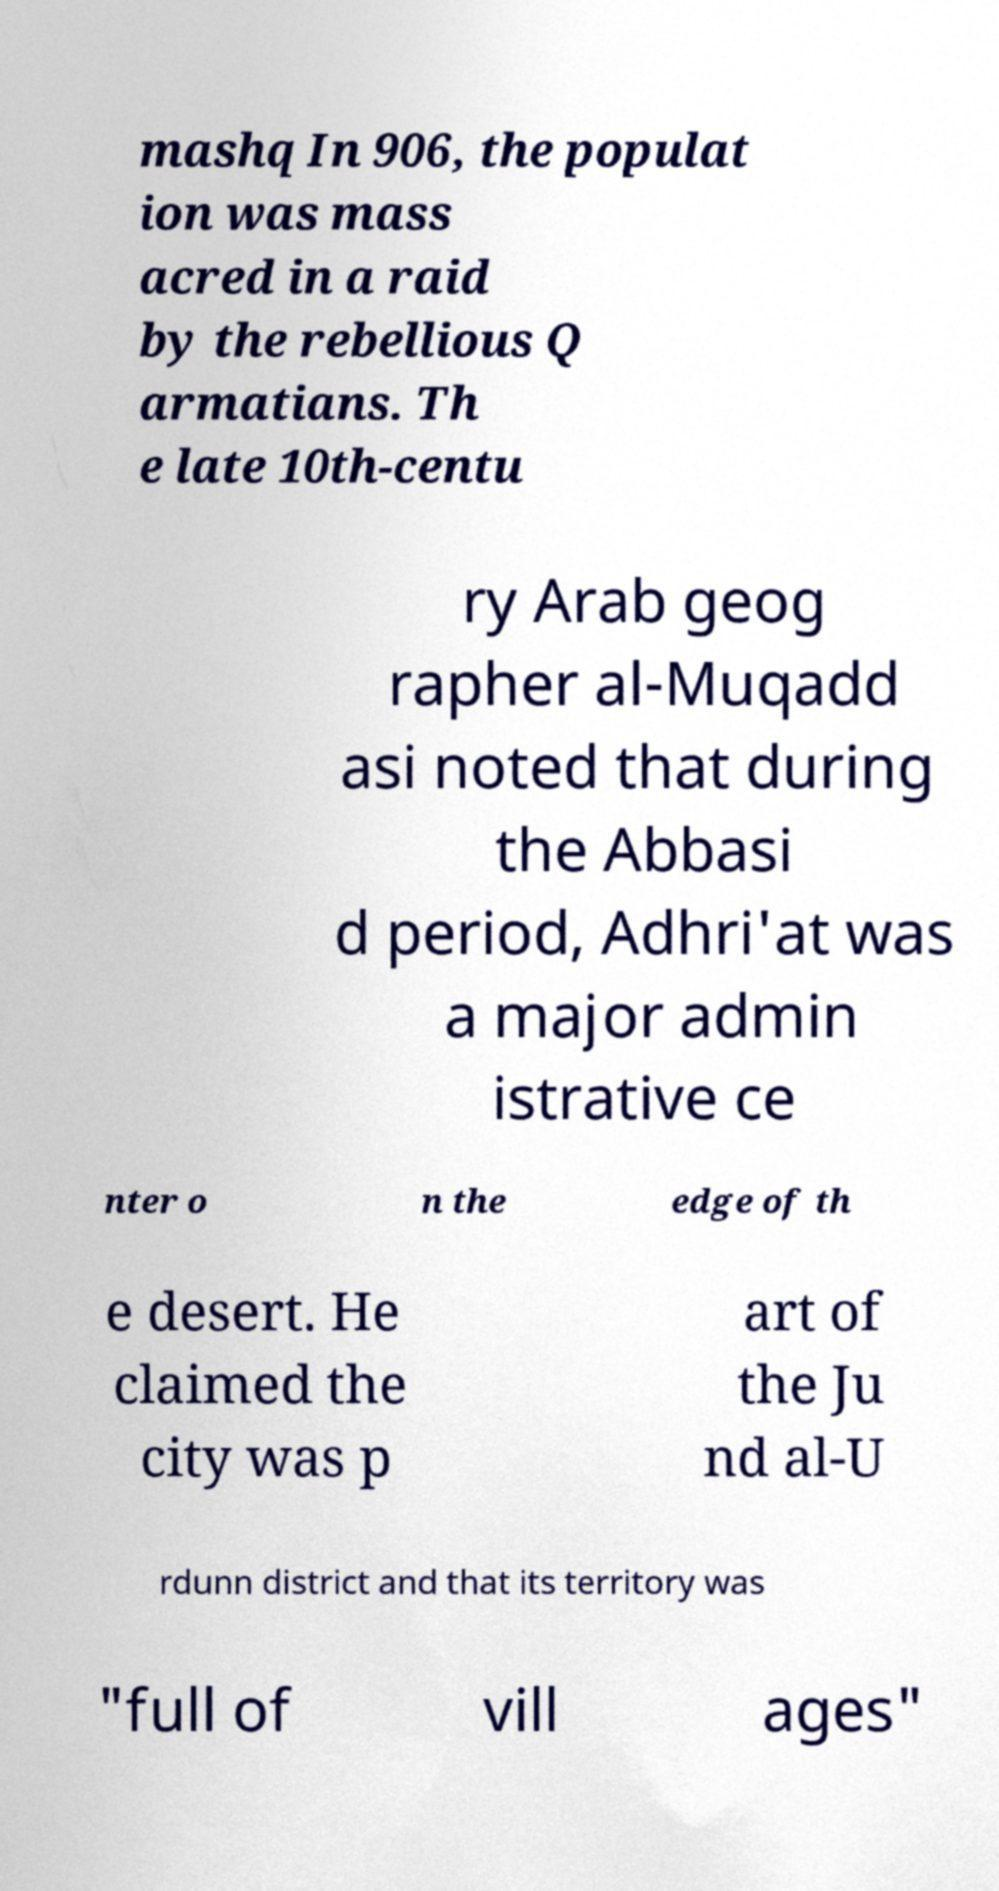Can you accurately transcribe the text from the provided image for me? mashq In 906, the populat ion was mass acred in a raid by the rebellious Q armatians. Th e late 10th-centu ry Arab geog rapher al-Muqadd asi noted that during the Abbasi d period, Adhri'at was a major admin istrative ce nter o n the edge of th e desert. He claimed the city was p art of the Ju nd al-U rdunn district and that its territory was "full of vill ages" 